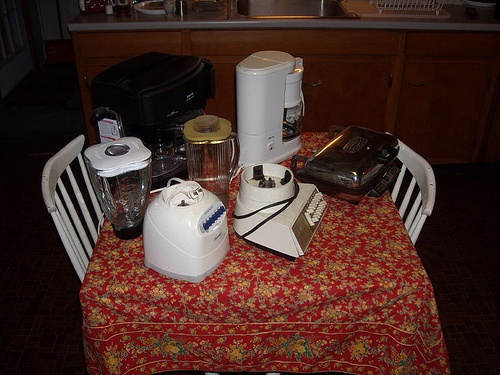Describe the objects in this image and their specific colors. I can see dining table in black, maroon, and darkgray tones, chair in black, darkgray, and gray tones, and chair in black, darkgray, and gray tones in this image. 